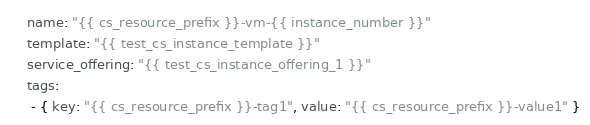<code> <loc_0><loc_0><loc_500><loc_500><_YAML_>    name: "{{ cs_resource_prefix }}-vm-{{ instance_number }}"
    template: "{{ test_cs_instance_template }}"
    service_offering: "{{ test_cs_instance_offering_1 }}"
    tags:
     - { key: "{{ cs_resource_prefix }}-tag1", value: "{{ cs_resource_prefix }}-value1" }</code> 